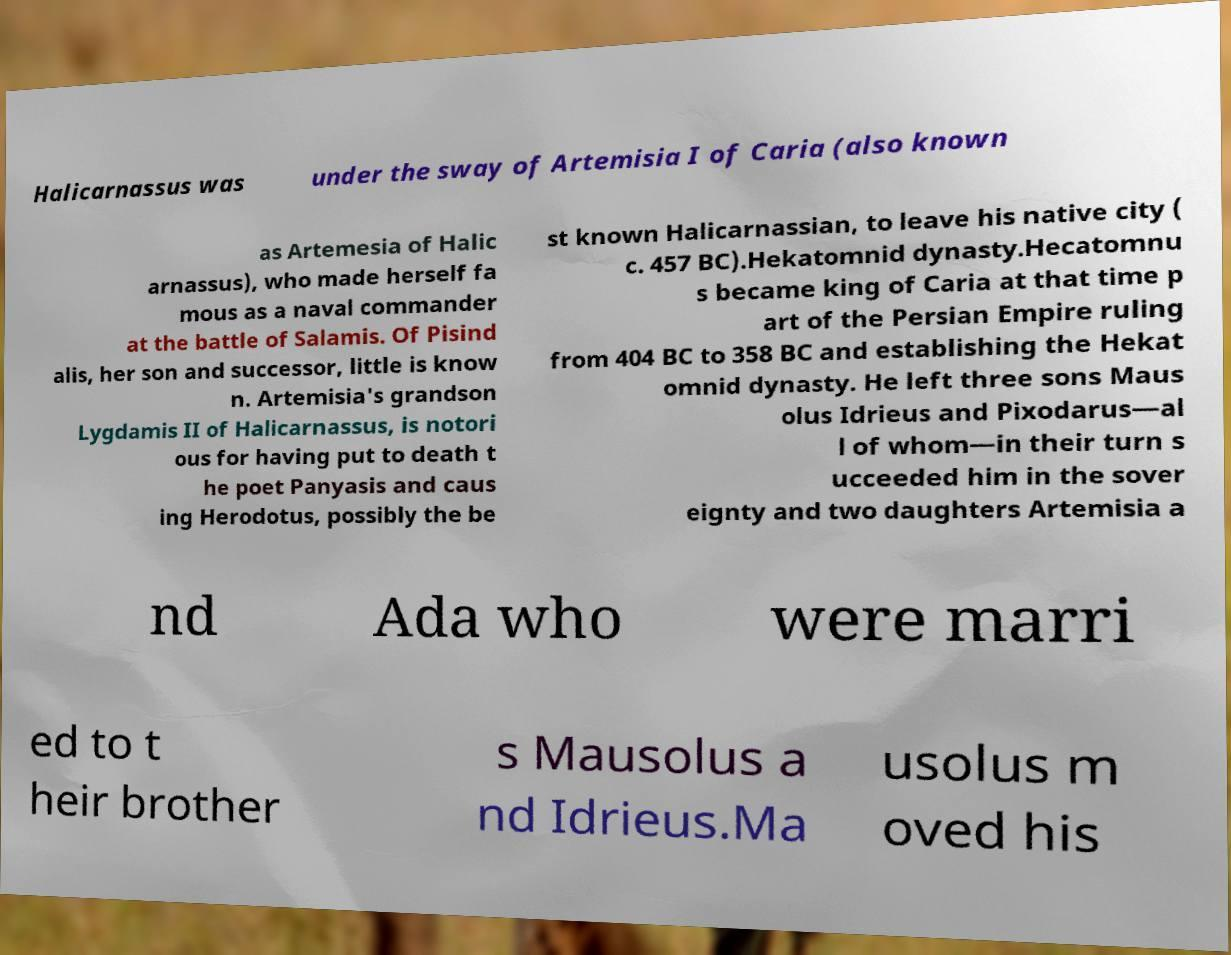There's text embedded in this image that I need extracted. Can you transcribe it verbatim? Halicarnassus was under the sway of Artemisia I of Caria (also known as Artemesia of Halic arnassus), who made herself fa mous as a naval commander at the battle of Salamis. Of Pisind alis, her son and successor, little is know n. Artemisia's grandson Lygdamis II of Halicarnassus, is notori ous for having put to death t he poet Panyasis and caus ing Herodotus, possibly the be st known Halicarnassian, to leave his native city ( c. 457 BC).Hekatomnid dynasty.Hecatomnu s became king of Caria at that time p art of the Persian Empire ruling from 404 BC to 358 BC and establishing the Hekat omnid dynasty. He left three sons Maus olus Idrieus and Pixodarus—al l of whom—in their turn s ucceeded him in the sover eignty and two daughters Artemisia a nd Ada who were marri ed to t heir brother s Mausolus a nd Idrieus.Ma usolus m oved his 